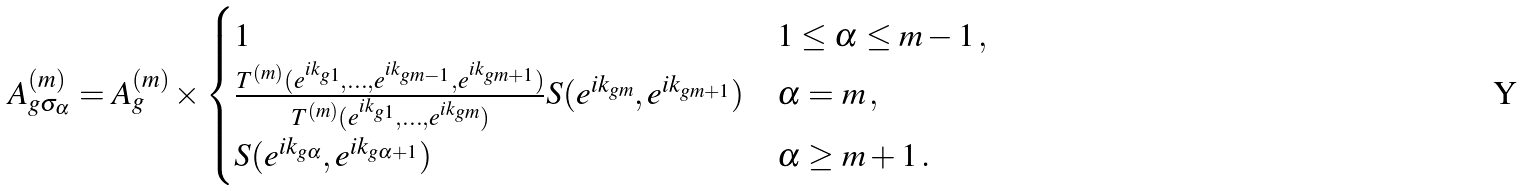<formula> <loc_0><loc_0><loc_500><loc_500>A _ { g \sigma _ { \alpha } } ^ { ( m ) } = A _ { g } ^ { ( m ) } \times \begin{cases} 1 & 1 \leq \alpha \leq m - 1 \, , \\ \frac { T ^ { ( m ) } ( e ^ { i k _ { g 1 } } , \dots , e ^ { i k _ { g m - 1 } } , e ^ { i k _ { g m + 1 } } ) } { T ^ { ( m ) } ( e ^ { i k _ { g 1 } } , \dots , e ^ { i k _ { g m } } ) } S ( e ^ { i k _ { g m } } , e ^ { i k _ { g m + 1 } } ) & \alpha = m \, , \\ S ( e ^ { i k _ { g \alpha } } , e ^ { i k _ { g \alpha + 1 } } ) & \alpha \geq m + 1 \, . \end{cases}</formula> 